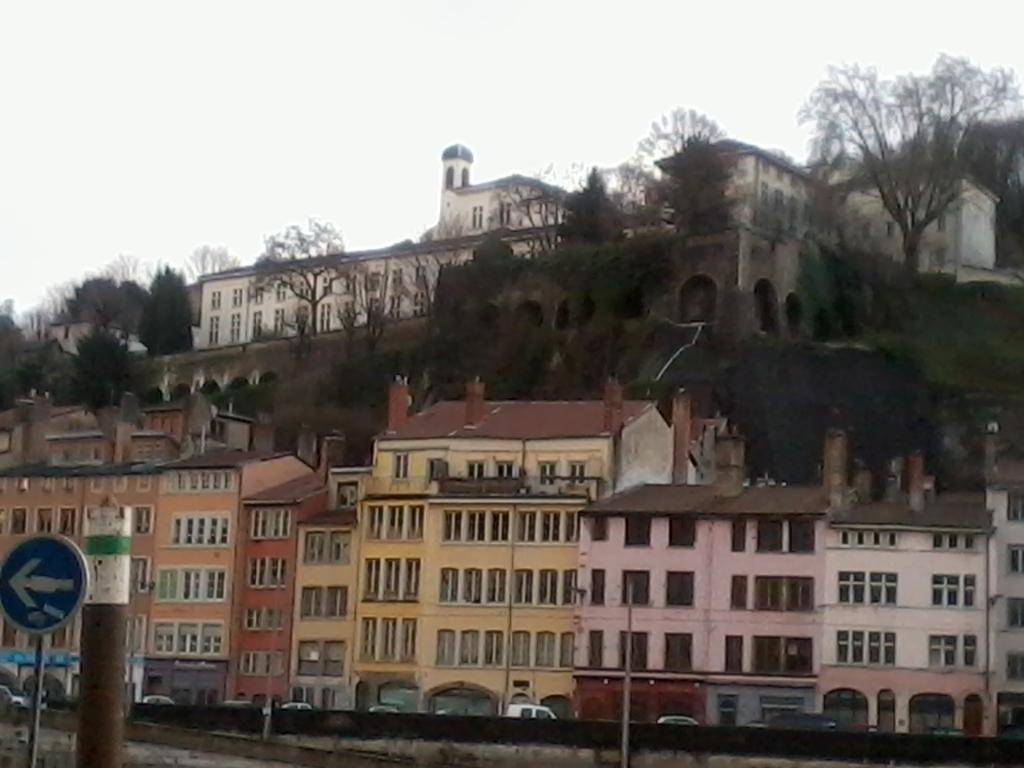What type of structures can be seen in the image? There are buildings in the image. What other natural elements are present in the image? There are trees in the image. What object is located in the front of the image? There is a pole in the front of the image. What man-made object provides information or direction in the image? There is a sign board in the image. What type of transportation can be seen on the left side of the image? Vehicles are present on the left side of the image. What is the weather condition in the image? The sky is cloudy in the image. What flavor of root can be seen growing near the buildings in the image? There is no root or mention of a specific flavor in the image; it features buildings, trees, a pole, a sign board, vehicles, and a cloudy sky. 